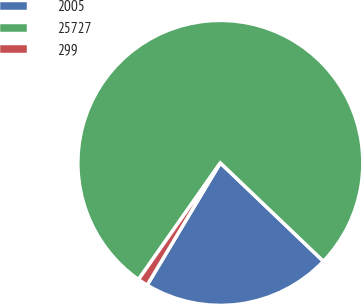Convert chart to OTSL. <chart><loc_0><loc_0><loc_500><loc_500><pie_chart><fcel>2005<fcel>25727<fcel>299<nl><fcel>21.46%<fcel>77.4%<fcel>1.15%<nl></chart> 